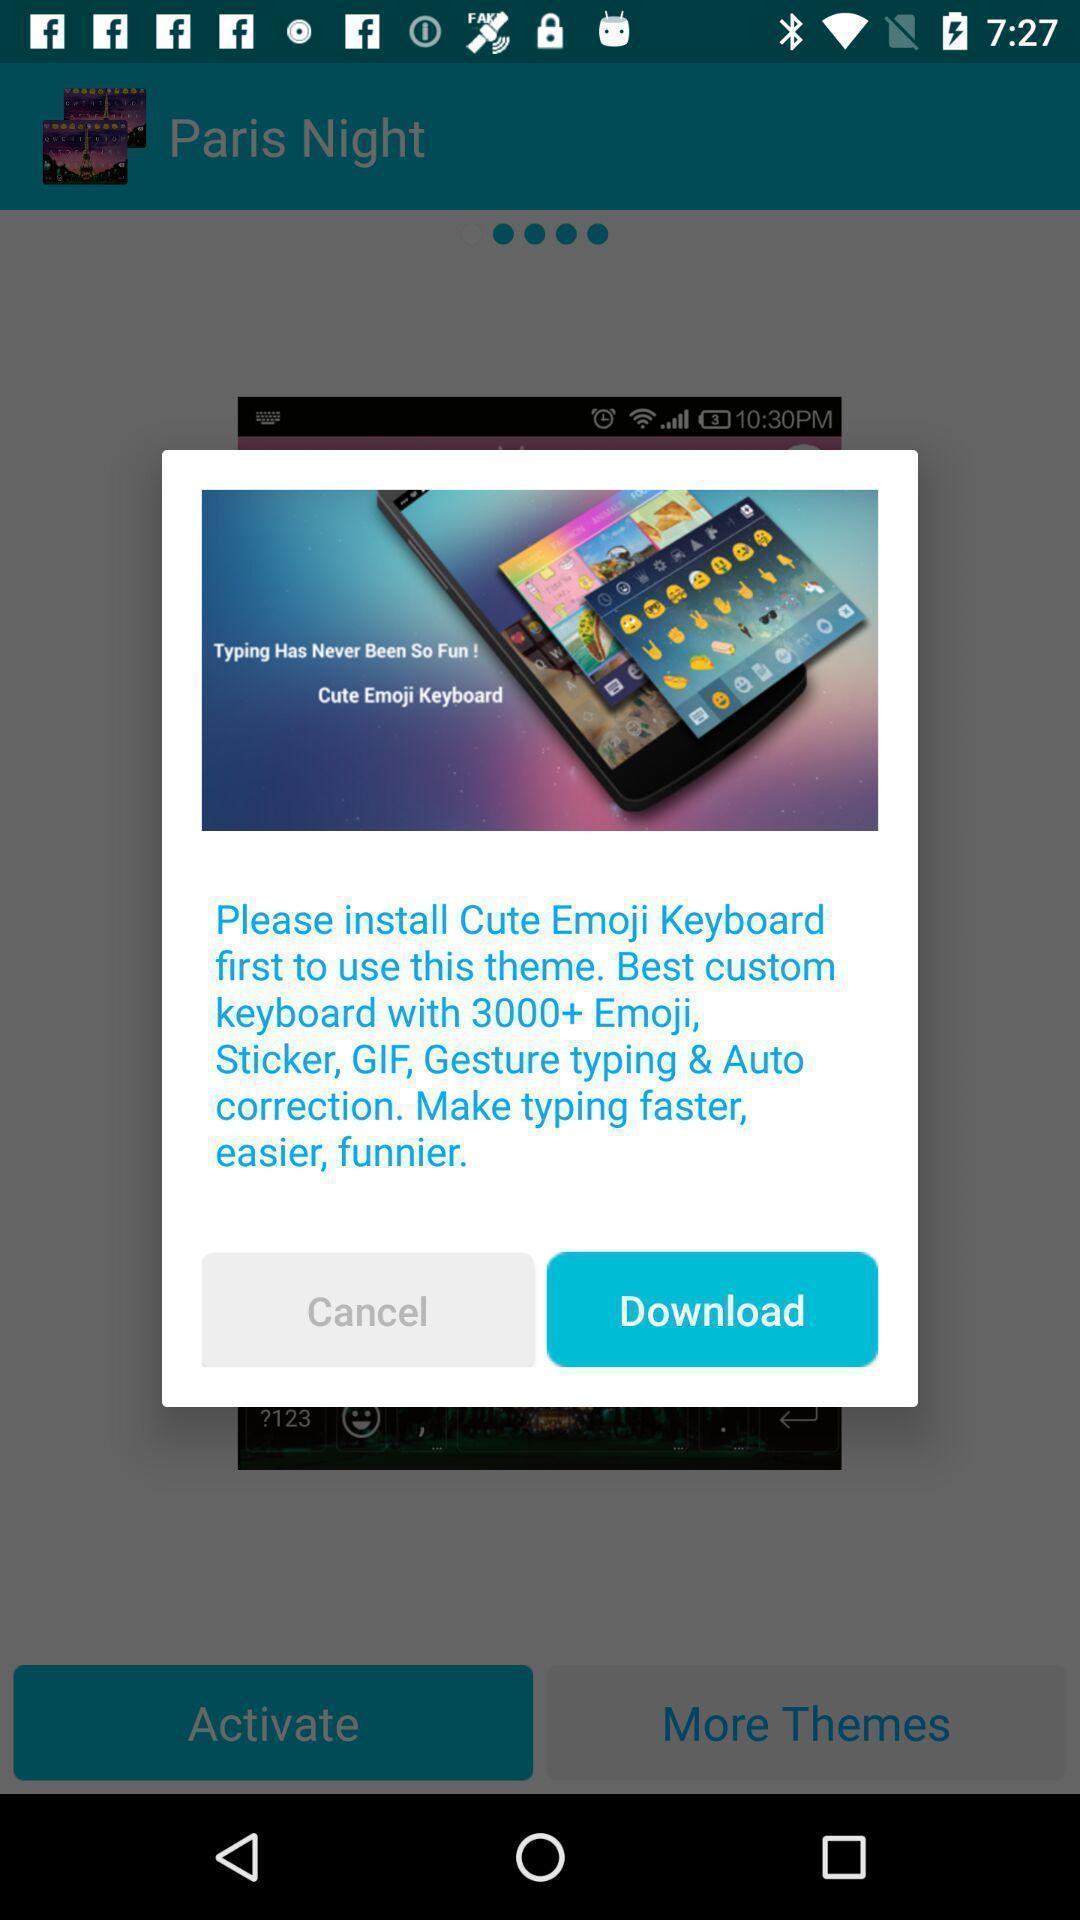What is the overall content of this screenshot? Popup showing install cute emoji keyboard. 